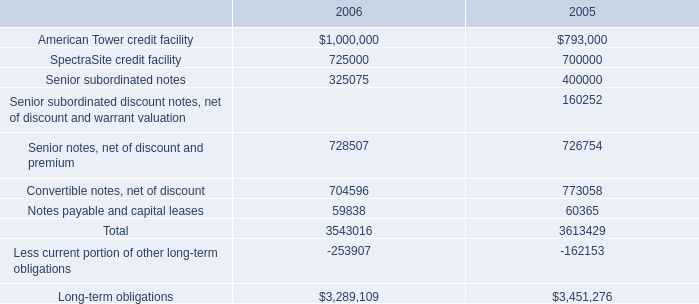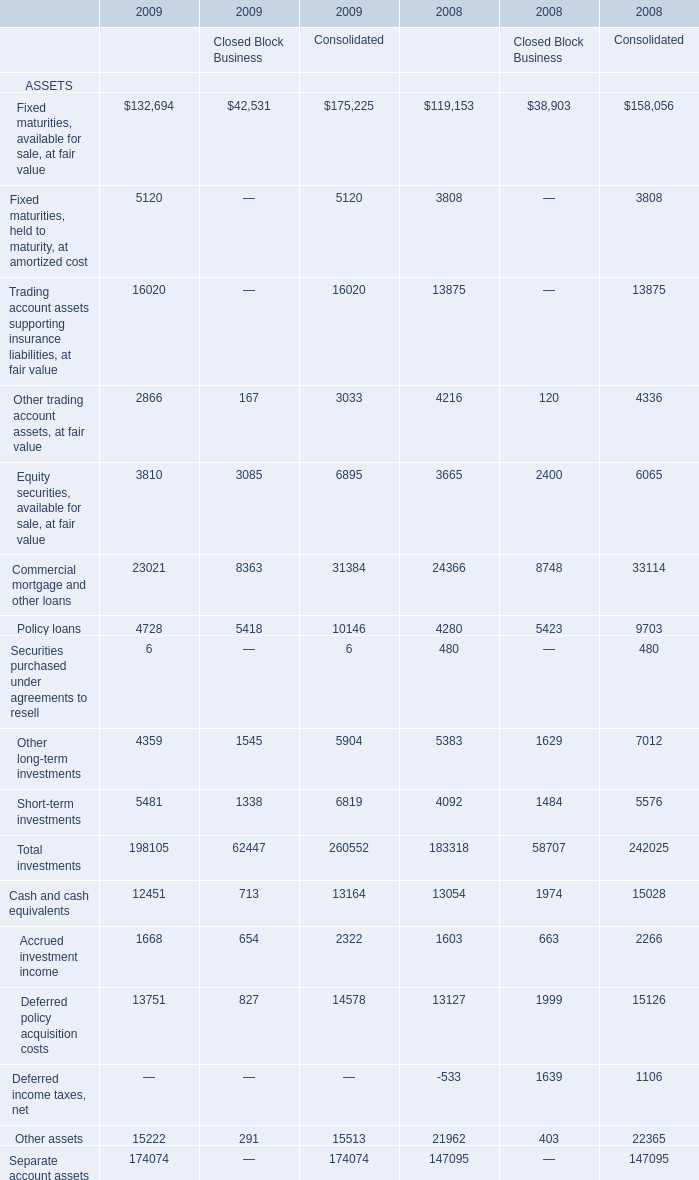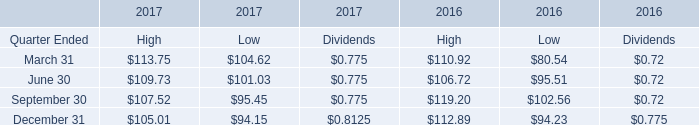Which year is Other long-term investments for Consolidated the lowest? 
Answer: 2009. 